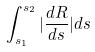<formula> <loc_0><loc_0><loc_500><loc_500>\int _ { s _ { 1 } } ^ { s _ { 2 } } | \frac { d R } { d s } | d s</formula> 